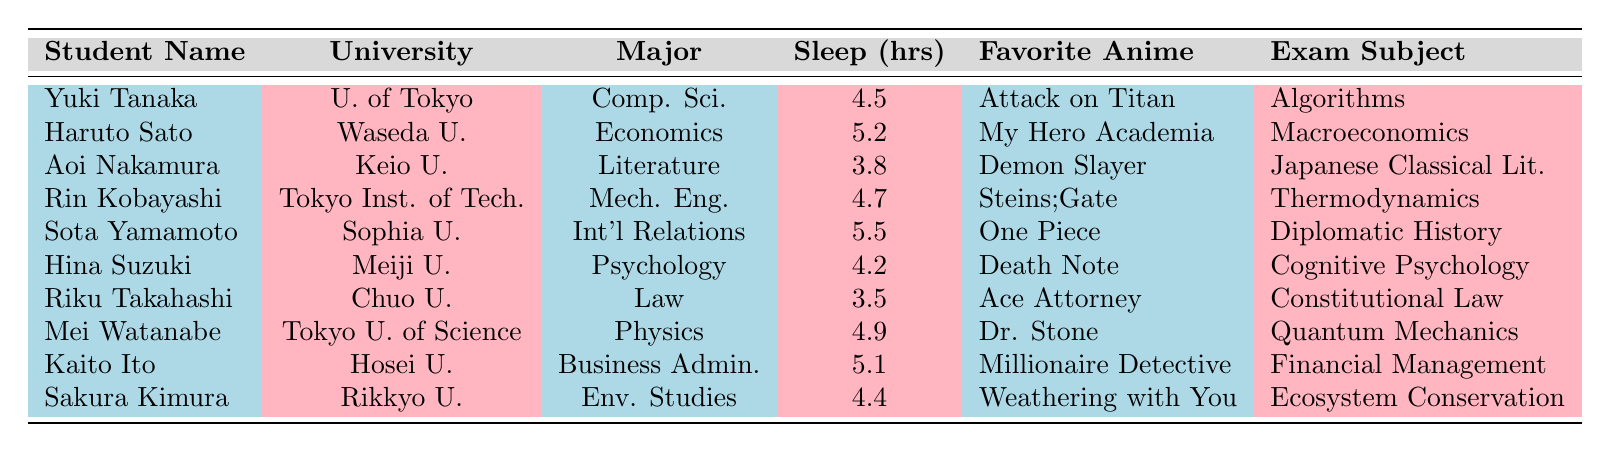What is the sleep duration of Yuki Tanaka? Yuki Tanaka's sleep duration is listed in the table under the "Sleep (hrs)" column as 4.5 hours.
Answer: 4.5 Which student has the longest sleep duration? By comparing the sleep durations from the "Sleep (hrs)" column, Sota Yamamoto has the longest sleep duration of 5.5 hours.
Answer: Sota Yamamoto How many students have a sleep duration of less than 4 hours? By checking the "Sleep (hrs)" column, there are no students listed with a sleep duration of less than 4 hours.
Answer: 0 What is the average sleep duration of students from the University of Tokyo and Waseda University? The sleep durations for the students from those universities are 4.5 hours (U. of Tokyo) and 5.2 hours (Waseda U). To find the average: (4.5 + 5.2) / 2 = 4.85.
Answer: 4.85 Who is the student that loves "Death Note" and what is their sleep duration? The student who loves "Death Note" is Hina Suzuki, whose sleep duration is listed as 4.2 hours in the table.
Answer: Hina Suzuki, 4.2 Is there any student whose favorite anime is "One Piece" and has a sleep duration of over 5 hours? Yes, Sota Yamamoto's favorite anime is "One Piece" and he has a sleep duration of 5.5 hours, which is over 5 hours.
Answer: Yes What is the difference in sleep duration between the student who studies Mechanical Engineering and the one who studies Economics? The sleep duration for Rin Kobayashi (Mechanical Engineering) is 4.7 hours, and for Haruto Sato (Economics) it is 5.2 hours. The difference is 5.2 - 4.7 = 0.5 hours.
Answer: 0.5 Which major has the student with the least sleep duration and what is that duration? Aoi Nakamura, who majors in Literature, has the least sleep duration at 3.8 hours, according to the table.
Answer: Literature, 3.8 What is the total sleep duration of students who study Psychology and Business Administration? Hina Suzuki (Psychology) has a sleep duration of 4.2 hours and Kaito Ito (Business Administration) has 5.1 hours. The total sleep duration is 4.2 + 5.1 = 9.3 hours.
Answer: 9.3 Which student has the same sleep duration as Sakura Kimura and what is that duration? Sakura Kimura has a sleep duration of 4.4 hours; Rin Kobayashi also has a sleep duration of 4.7, so none match. Therefore, no student has the same sleep duration as Sakura Kimura.
Answer: None 